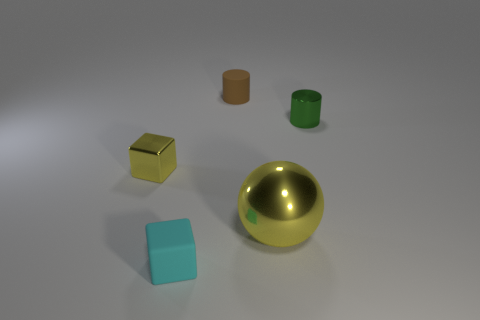Is there any other thing that has the same shape as the big metallic object?
Your answer should be very brief. No. Are there fewer large yellow shiny objects that are behind the matte block than green shiny cylinders?
Your answer should be compact. No. There is a small metallic object that is in front of the green thing; is its color the same as the large object?
Offer a very short reply. Yes. What number of metallic objects are either cubes or large yellow things?
Provide a succinct answer. 2. Is there any other thing that is the same size as the sphere?
Keep it short and to the point. No. What is the color of the tiny cube that is made of the same material as the green object?
Provide a short and direct response. Yellow. What number of cylinders are either large objects or tiny brown things?
Make the answer very short. 1. How many objects are blue metallic cylinders or small objects on the right side of the big yellow ball?
Give a very brief answer. 1. Are any tiny yellow cubes visible?
Your answer should be compact. Yes. What number of spheres are the same color as the tiny metallic block?
Your response must be concise. 1. 